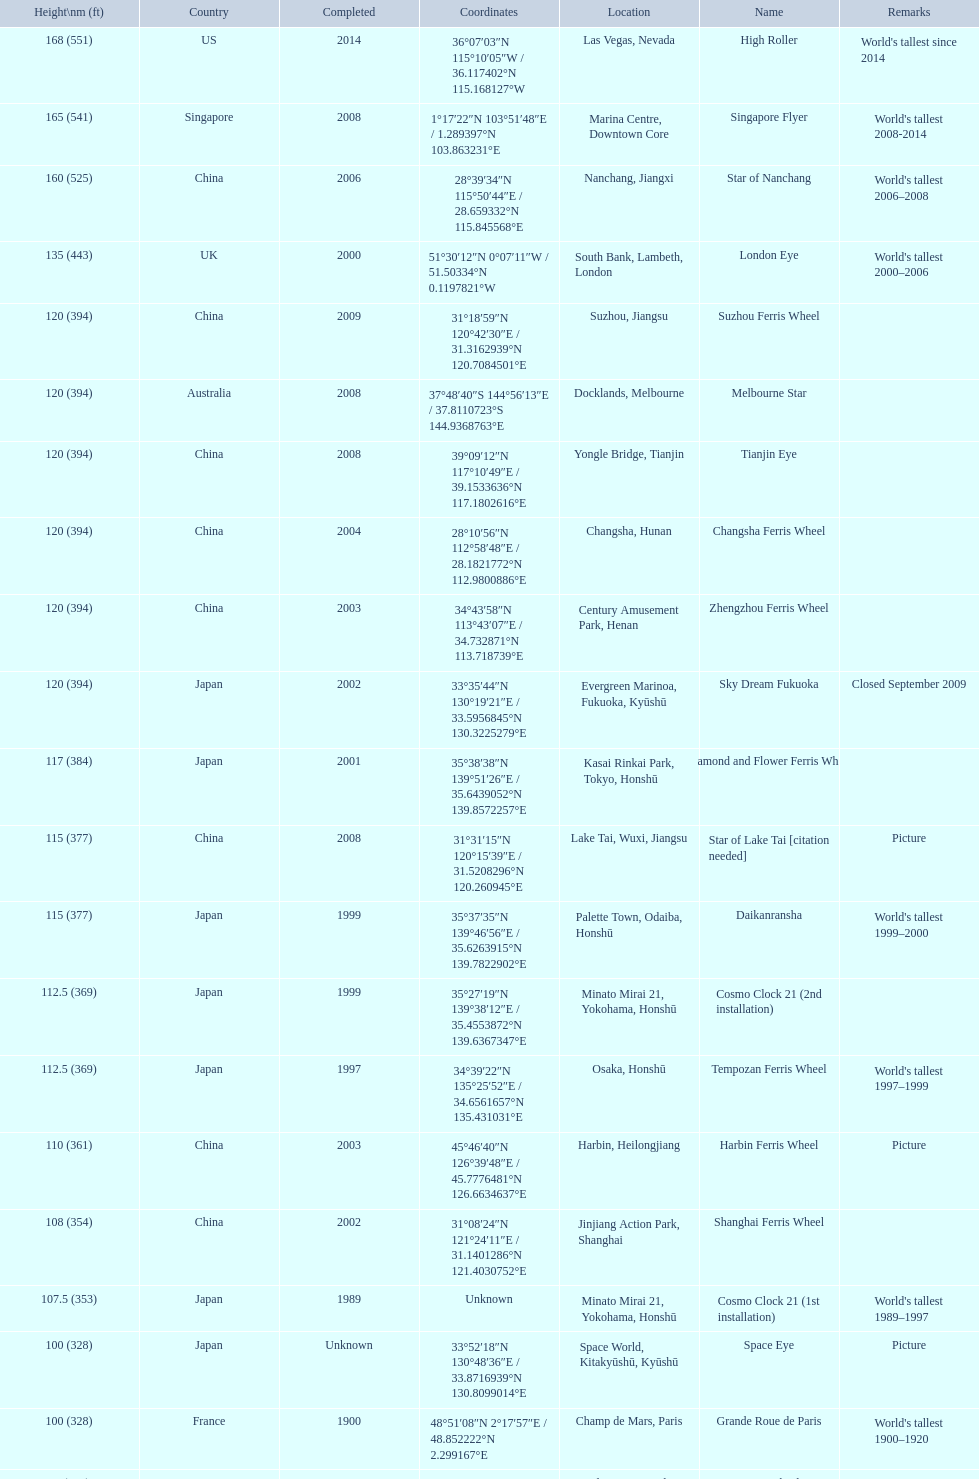Which of the following roller coasters is the oldest: star of lake tai, star of nanchang, melbourne star Star of Nanchang. 